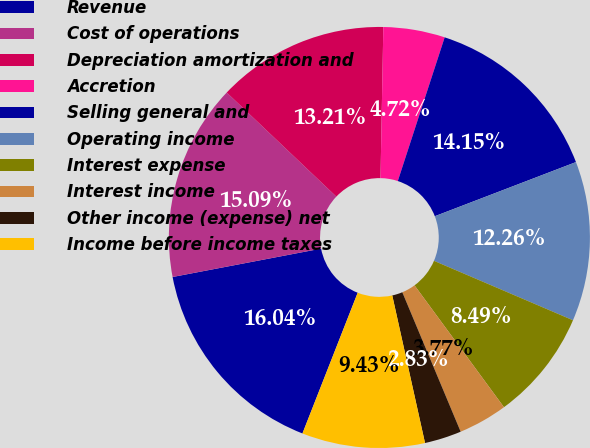Convert chart. <chart><loc_0><loc_0><loc_500><loc_500><pie_chart><fcel>Revenue<fcel>Cost of operations<fcel>Depreciation amortization and<fcel>Accretion<fcel>Selling general and<fcel>Operating income<fcel>Interest expense<fcel>Interest income<fcel>Other income (expense) net<fcel>Income before income taxes<nl><fcel>16.04%<fcel>15.09%<fcel>13.21%<fcel>4.72%<fcel>14.15%<fcel>12.26%<fcel>8.49%<fcel>3.77%<fcel>2.83%<fcel>9.43%<nl></chart> 